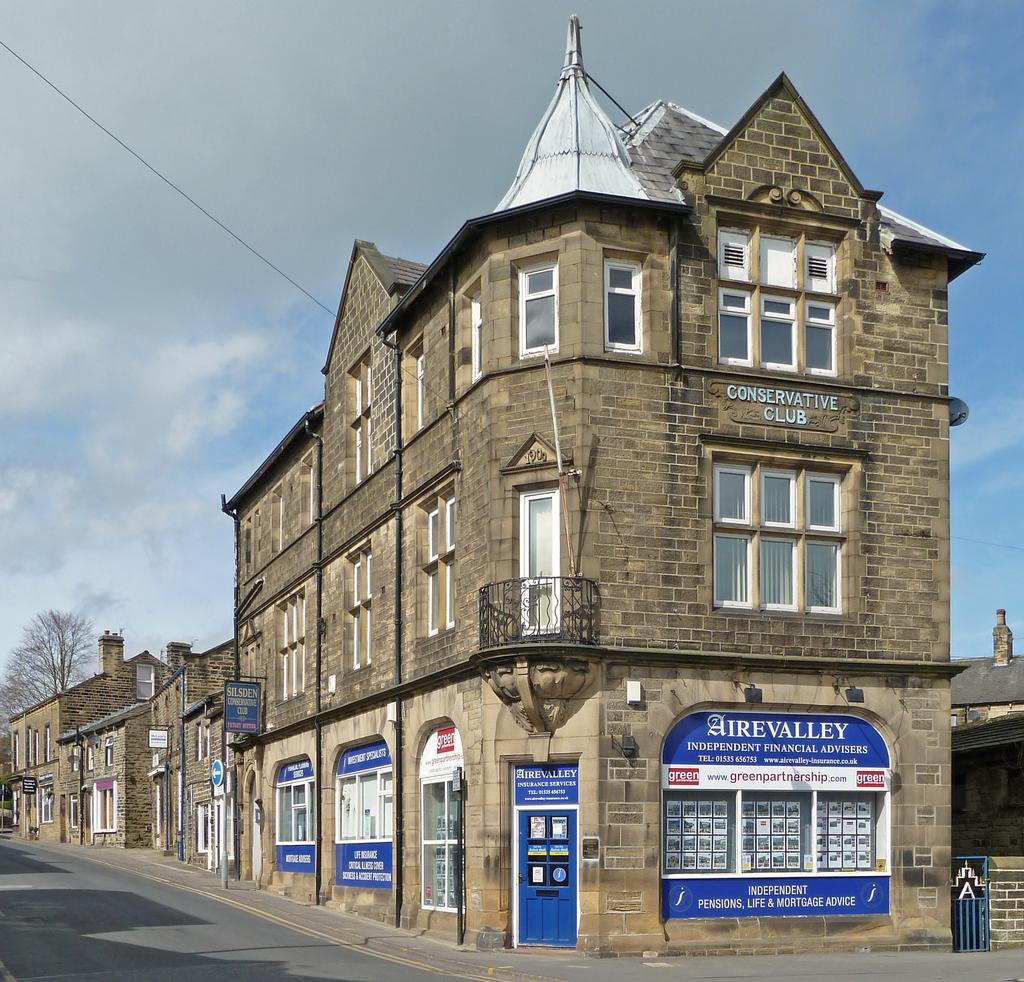Can you describe this image briefly? In this image there are buildings one beside the other. In front of the building there is a road. On the footpath there are poles and trees. At the top there is sky. 